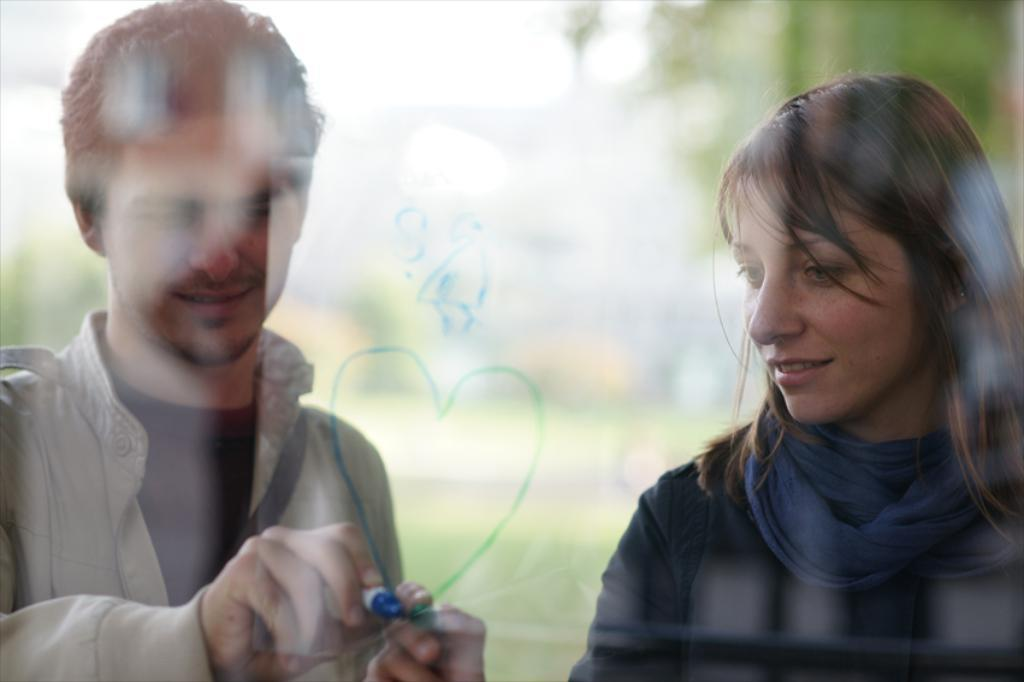What object is visible in the image that is typically used for drinking? There is a glass in the image. What are the two persons in the image doing? The two persons are holding an object in the image. What can be seen in the distance in the image? There are trees in the background of the image. What type of sand can be seen in the image? There is no sand present in the image. How many stars are visible in the image? There are no stars visible in the image. 